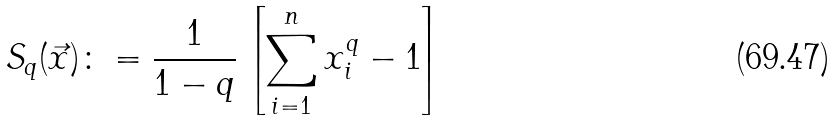<formula> <loc_0><loc_0><loc_500><loc_500>S _ { q } ( \vec { x } ) \colon = \frac { 1 } { 1 - q } \left [ \sum _ { i = 1 } ^ { n } x _ { i } ^ { q } - 1 \right ] \</formula> 